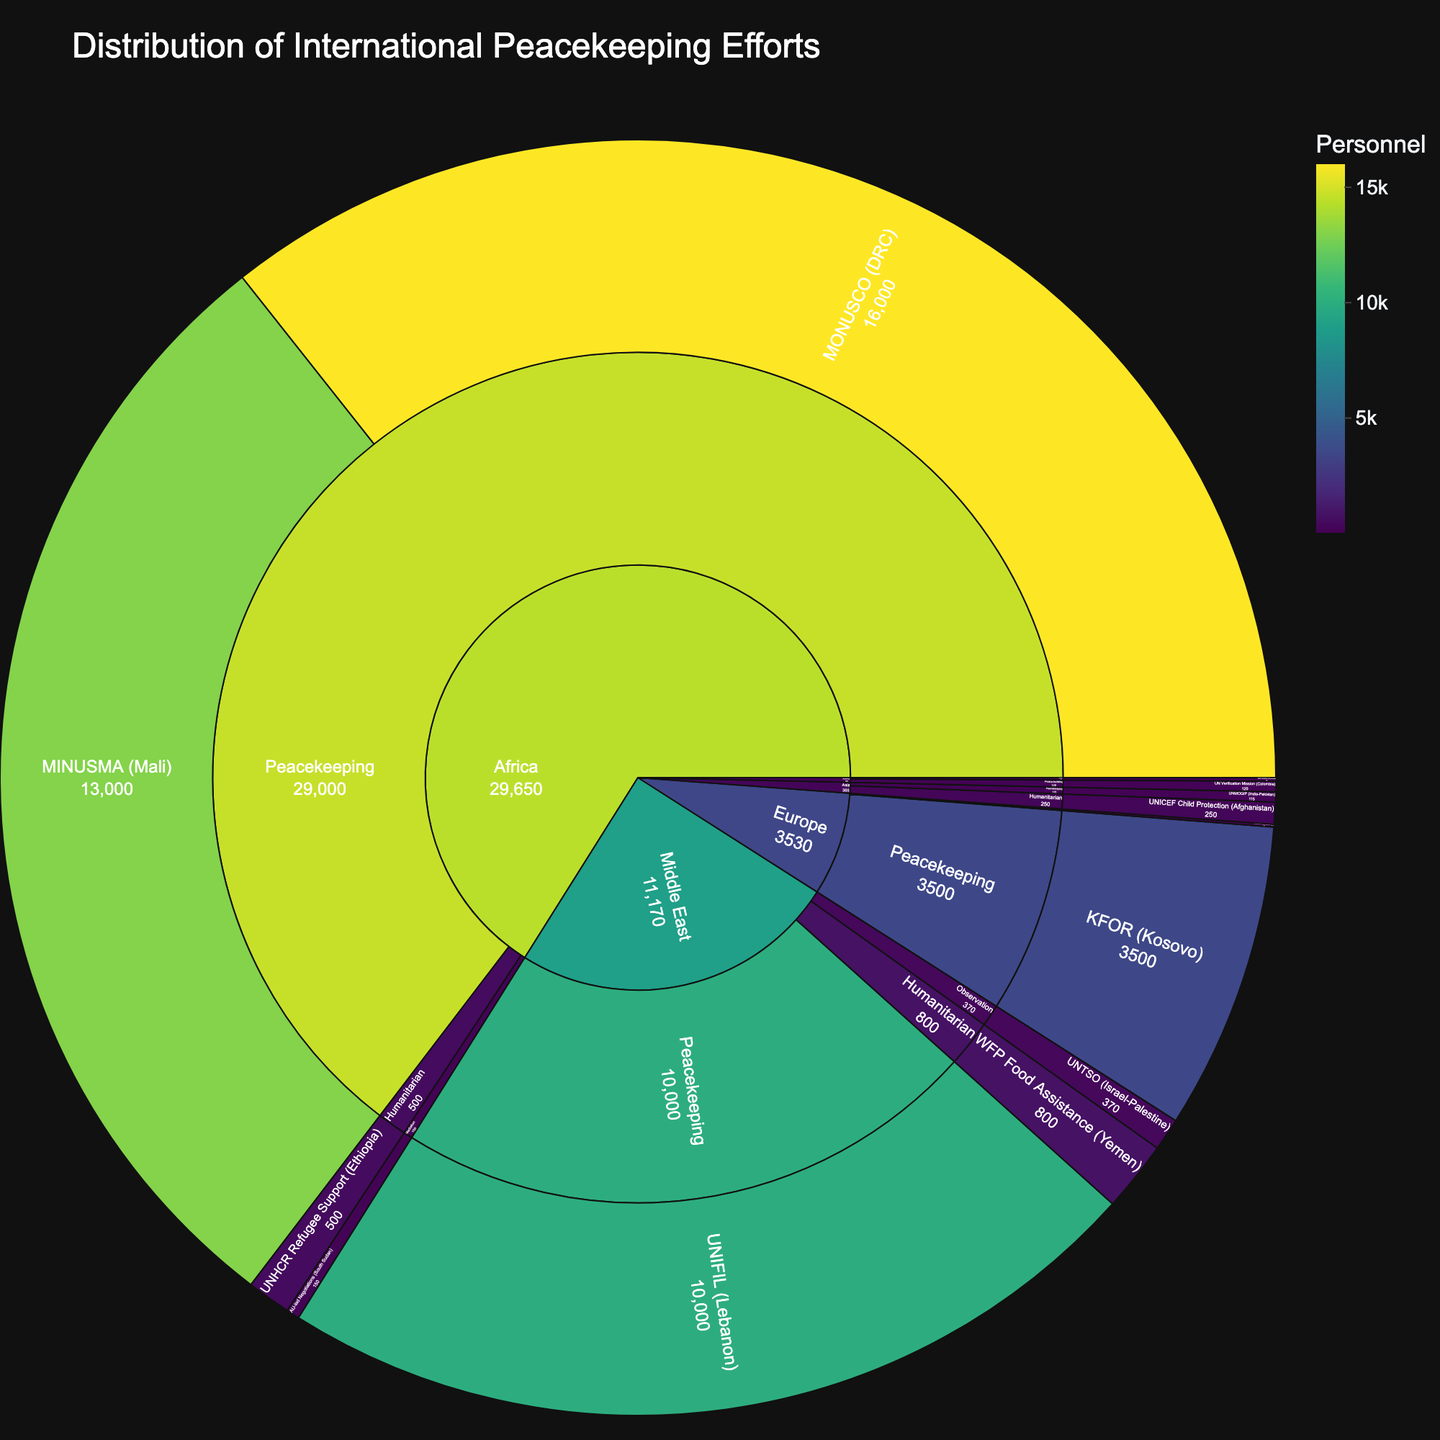What region has the highest number of personnel involved in international peacekeeping efforts? By looking at the segment size in the figure, the region with the largest area in the peacekeeping category represents the region with the highest personnel. Africa has the largest segment within peacekeeping, indicating the highest number of personnel.
Answer: Africa Which specific effort in Asia has the highest personnel? By zooming into the Asia region in the sunburst plot and checking the segments, UNMOGIP (India-Pakistan) has the highest personnel since it is the largest segment within Asia.
Answer: UNMOGIP (India-Pakistan) How many personnel are involved in humanitarian efforts in the Middle East? Adding the personnel numbers within the humanitarian category under the Middle East: WFP Food Assistance (Yemen) has 800 personnel.
Answer: 800 Compare the number of personnel involved in peacekeeping efforts between Africa and Europe. By observing the segments in the peacekeeping category, Africa has MINUSMA (Mali) with 13000 personnel and MONUSCO (DRC) with 16000 personnel, totaling 29000. Europe has KFOR (Kosovo) with 3500 personnel. Africa clearly has more personnel in peacekeeping.
Answer: Africa: 29000, Europe: 3500 What is the total number of personnel involved in mediation efforts across all regions? Summing the personnel in mediation efforts: Africa: 150, Europe: 30, Americas: 40. So, the total is 150 + 30 + 40 = 220.
Answer: 220 Which type of intervention in the Middle East has the second-largest number of personnel? By examining the segments for the Middle East, the largest segment is Peacekeeping with 10000 personnel. The next largest is Observation with 370 personnel.
Answer: Observation What specific humanitarian effort in Africa has how many personnel? Within the Africa region, the humanitarian category includes UNHCR Refugee Support (Ethiopia) with 500 personnel.
Answer: UNHCR Refugee Support (Ethiopia): 500 How does the number of personnel in the UN Verification Mission (Colombia) compare to the total personnel in Asia? The UN Verification Mission in Colombia has 120 personnel. In Asia, totaling the numbers: UNMOGIP (India-Pakistan) with 115, and UNICEF Child Protection (Afghanistan) with 250, gives 115 + 250 = 365. The mission in Colombia has fewer personnel.
Answer: UN Verification Mission: 120, Asia total: 365 What is the total number of personnel deployed in peacekeeping efforts across all regions? Summing personnel numbers from the peacekeeping category: Africa: 13000 + 16000 = 29000, Middle East: 10000, Europe: 3500, Asia: 115. Total is 29000 + 10000 + 3500 + 115 = 42615.
Answer: 42615 